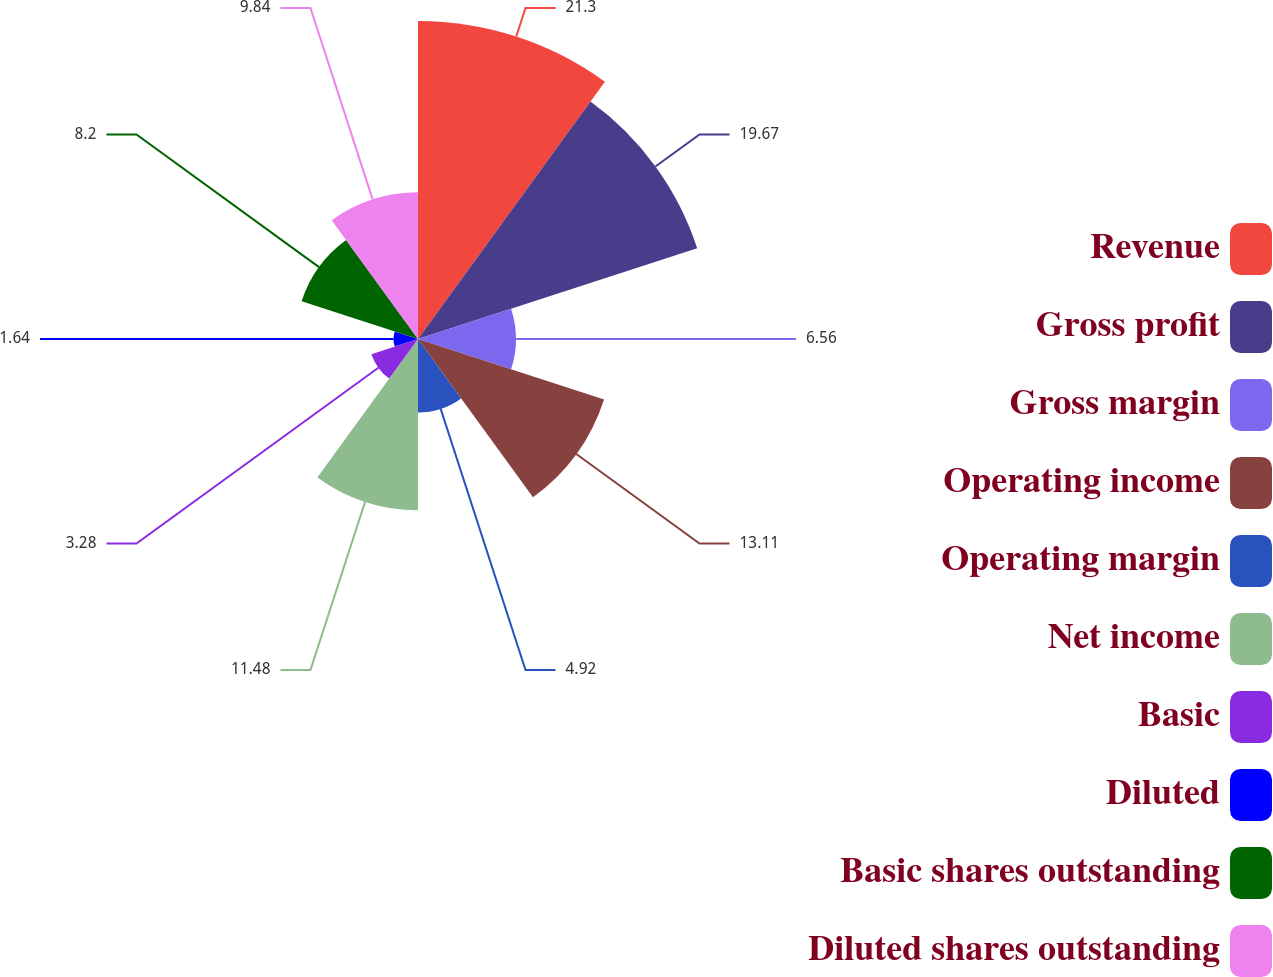Convert chart. <chart><loc_0><loc_0><loc_500><loc_500><pie_chart><fcel>Revenue<fcel>Gross profit<fcel>Gross margin<fcel>Operating income<fcel>Operating margin<fcel>Net income<fcel>Basic<fcel>Diluted<fcel>Basic shares outstanding<fcel>Diluted shares outstanding<nl><fcel>21.31%<fcel>19.67%<fcel>6.56%<fcel>13.11%<fcel>4.92%<fcel>11.48%<fcel>3.28%<fcel>1.64%<fcel>8.2%<fcel>9.84%<nl></chart> 